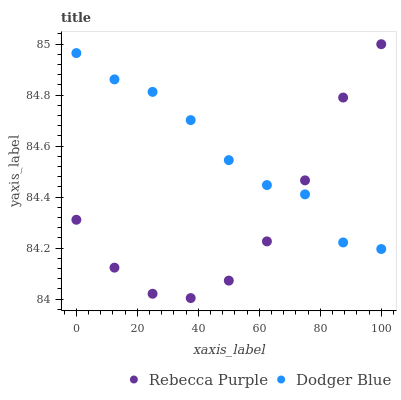Does Rebecca Purple have the minimum area under the curve?
Answer yes or no. Yes. Does Dodger Blue have the maximum area under the curve?
Answer yes or no. Yes. Does Rebecca Purple have the maximum area under the curve?
Answer yes or no. No. Is Dodger Blue the smoothest?
Answer yes or no. Yes. Is Rebecca Purple the roughest?
Answer yes or no. Yes. Is Rebecca Purple the smoothest?
Answer yes or no. No. Does Rebecca Purple have the lowest value?
Answer yes or no. Yes. Does Rebecca Purple have the highest value?
Answer yes or no. Yes. Does Dodger Blue intersect Rebecca Purple?
Answer yes or no. Yes. Is Dodger Blue less than Rebecca Purple?
Answer yes or no. No. Is Dodger Blue greater than Rebecca Purple?
Answer yes or no. No. 